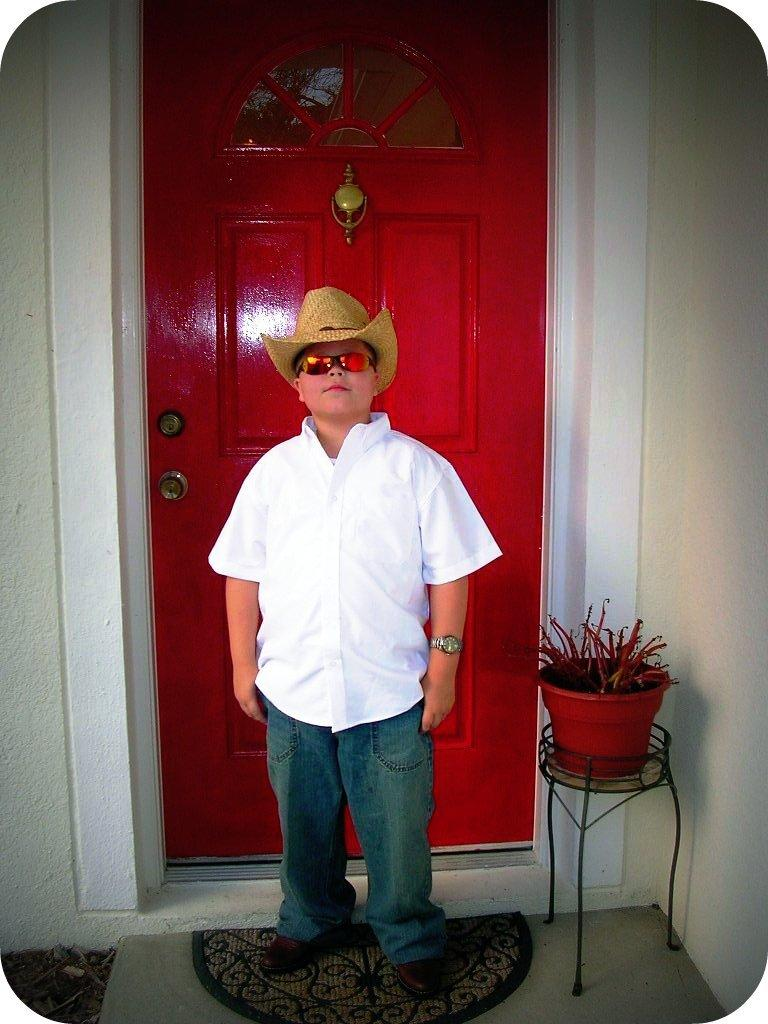Who is present in the image? There is a boy in the image. What is the boy doing in the image? The boy is standing. What accessories is the boy wearing in the image? The boy is wearing glasses and a hat. What can be seen in the background of the image? There is a wall and a red door in the background of the image. What type of store can be seen near the seashore in the image? There is no store or seashore present in the image; it features a boy standing with a wall and a red door in the background. 